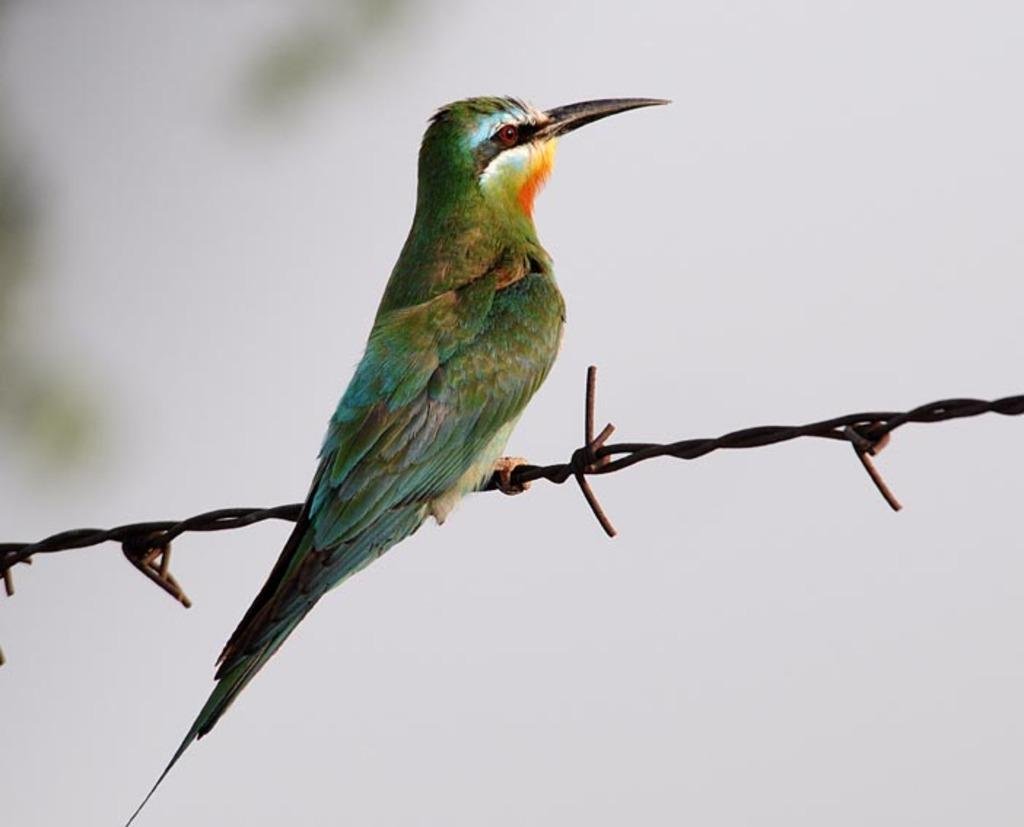What is the main subject in the foreground of the image? There is a beautiful bird in the foreground of the image. Where is the bird positioned in the image? The bird is on a barbed wire. What can be seen in the background of the image? The sky is visible in the background of the image. What type of oranges can be seen growing on the barbed wire in the image? There are no oranges present in the image; the bird is on a barbed wire, and the image does not depict any fruit. 